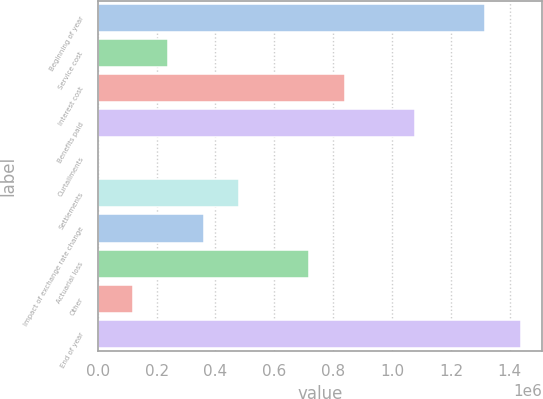Convert chart. <chart><loc_0><loc_0><loc_500><loc_500><bar_chart><fcel>Beginning of year<fcel>Service cost<fcel>Interest cost<fcel>Benefits paid<fcel>Curtailments<fcel>Settlements<fcel>Impact of exchange rate change<fcel>Actuarial loss<fcel>Other<fcel>End of year<nl><fcel>1.3168e+06<fcel>240280<fcel>838348<fcel>1.07758e+06<fcel>1053<fcel>479507<fcel>359894<fcel>718735<fcel>120667<fcel>1.43642e+06<nl></chart> 